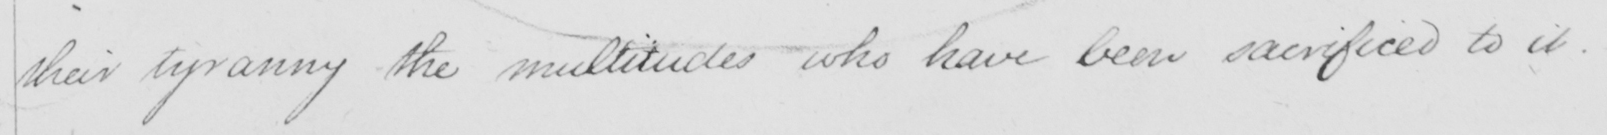Please transcribe the handwritten text in this image. their tyranny the multitudes who have been sacrificed to it .  _ 